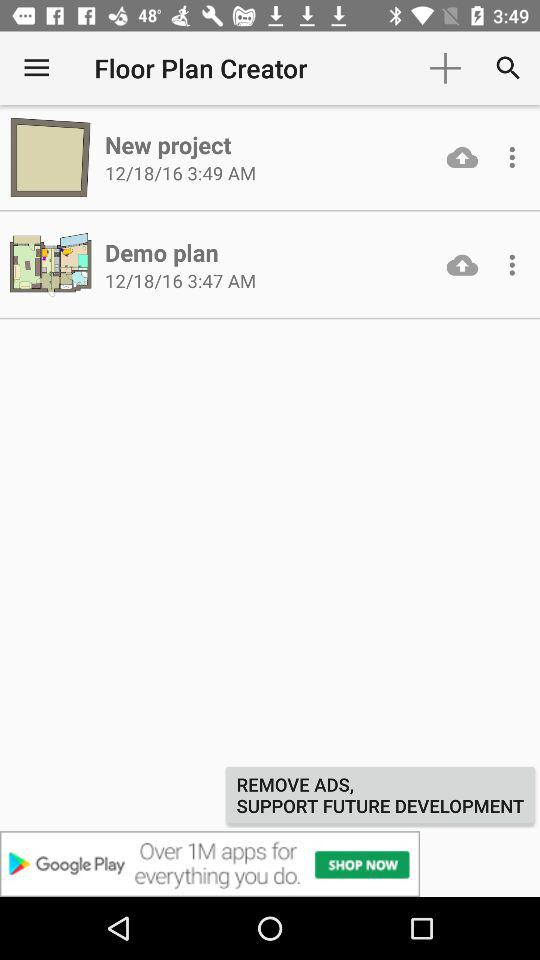When did the "Demo plan" get started? The "Demo plan" get started on December 18, 16 at 3:47 am. 